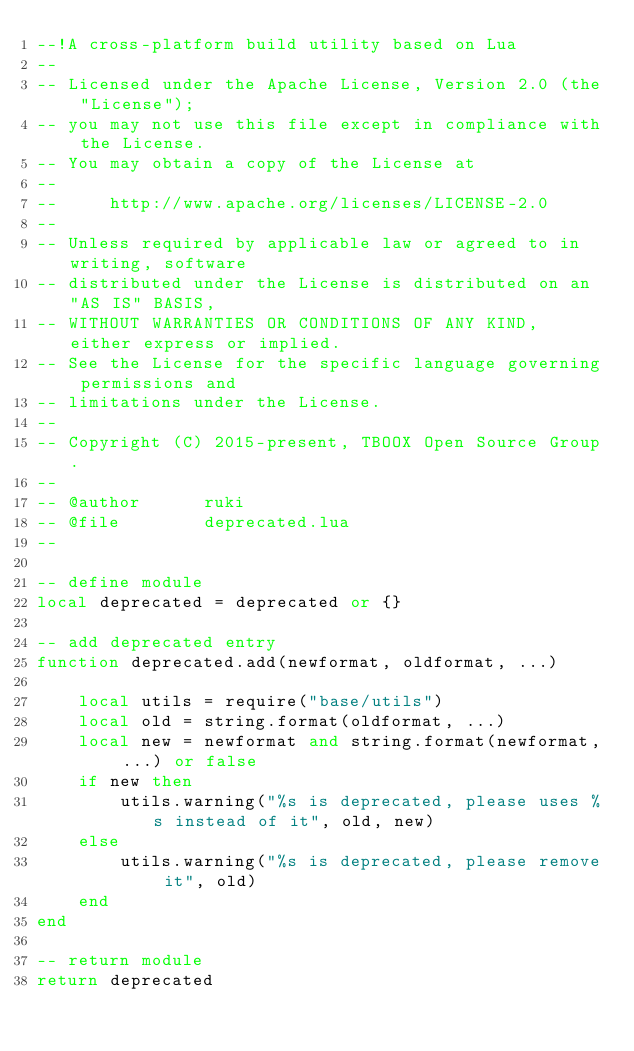<code> <loc_0><loc_0><loc_500><loc_500><_Lua_>--!A cross-platform build utility based on Lua
--
-- Licensed under the Apache License, Version 2.0 (the "License");
-- you may not use this file except in compliance with the License.
-- You may obtain a copy of the License at
--
--     http://www.apache.org/licenses/LICENSE-2.0
--
-- Unless required by applicable law or agreed to in writing, software
-- distributed under the License is distributed on an "AS IS" BASIS,
-- WITHOUT WARRANTIES OR CONDITIONS OF ANY KIND, either express or implied.
-- See the License for the specific language governing permissions and
-- limitations under the License.
--
-- Copyright (C) 2015-present, TBOOX Open Source Group.
--
-- @author      ruki
-- @file        deprecated.lua
--

-- define module
local deprecated = deprecated or {}

-- add deprecated entry
function deprecated.add(newformat, oldformat, ...)

    local utils = require("base/utils")
    local old = string.format(oldformat, ...)
    local new = newformat and string.format(newformat, ...) or false
    if new then
        utils.warning("%s is deprecated, please uses %s instead of it", old, new)
    else
        utils.warning("%s is deprecated, please remove it", old)
    end
end

-- return module
return deprecated
</code> 